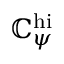Convert formula to latex. <formula><loc_0><loc_0><loc_500><loc_500>\mathbb { C } _ { \psi } ^ { h i }</formula> 